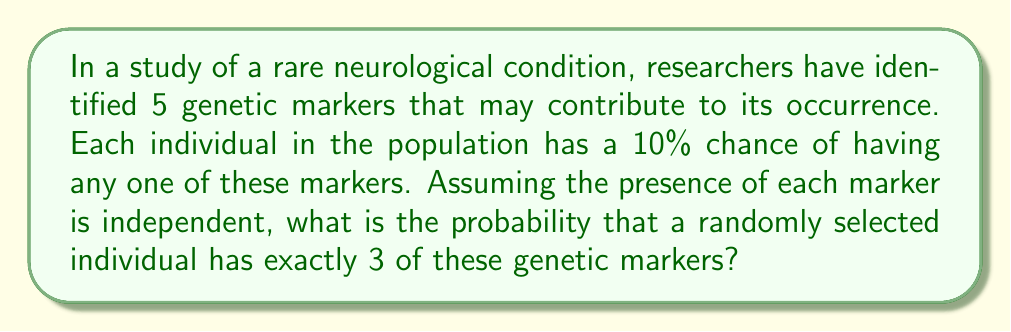Teach me how to tackle this problem. To solve this problem, we can use the concept of binomial probability from combinatorics. Let's break it down step-by-step:

1) First, we need to calculate the probability of having a marker (p) and not having a marker (q):
   $p = 0.10$ (given)
   $q = 1 - p = 0.90$

2) We want the probability of having exactly 3 markers out of 5. We can use the binomial probability formula:

   $P(X = k) = \binom{n}{k} p^k q^{n-k}$

   Where:
   $n = 5$ (total number of markers)
   $k = 3$ (number of markers we want)
   $p = 0.10$ (probability of having a marker)
   $q = 0.90$ (probability of not having a marker)

3) Let's calculate $\binom{5}{3}$:
   
   $\binom{5}{3} = \frac{5!}{3!(5-3)!} = \frac{5!}{3!2!} = 10$

4) Now, let's plug everything into the formula:

   $P(X = 3) = 10 \cdot (0.10)^3 \cdot (0.90)^{5-3}$

5) Simplify:
   
   $P(X = 3) = 10 \cdot (0.001) \cdot (0.81)$
   
   $P(X = 3) = 0.00810 = 0.0081$

Thus, the probability of a randomly selected individual having exactly 3 of these 5 genetic markers is 0.0081 or 0.81%.
Answer: 0.0081 or 0.81% 